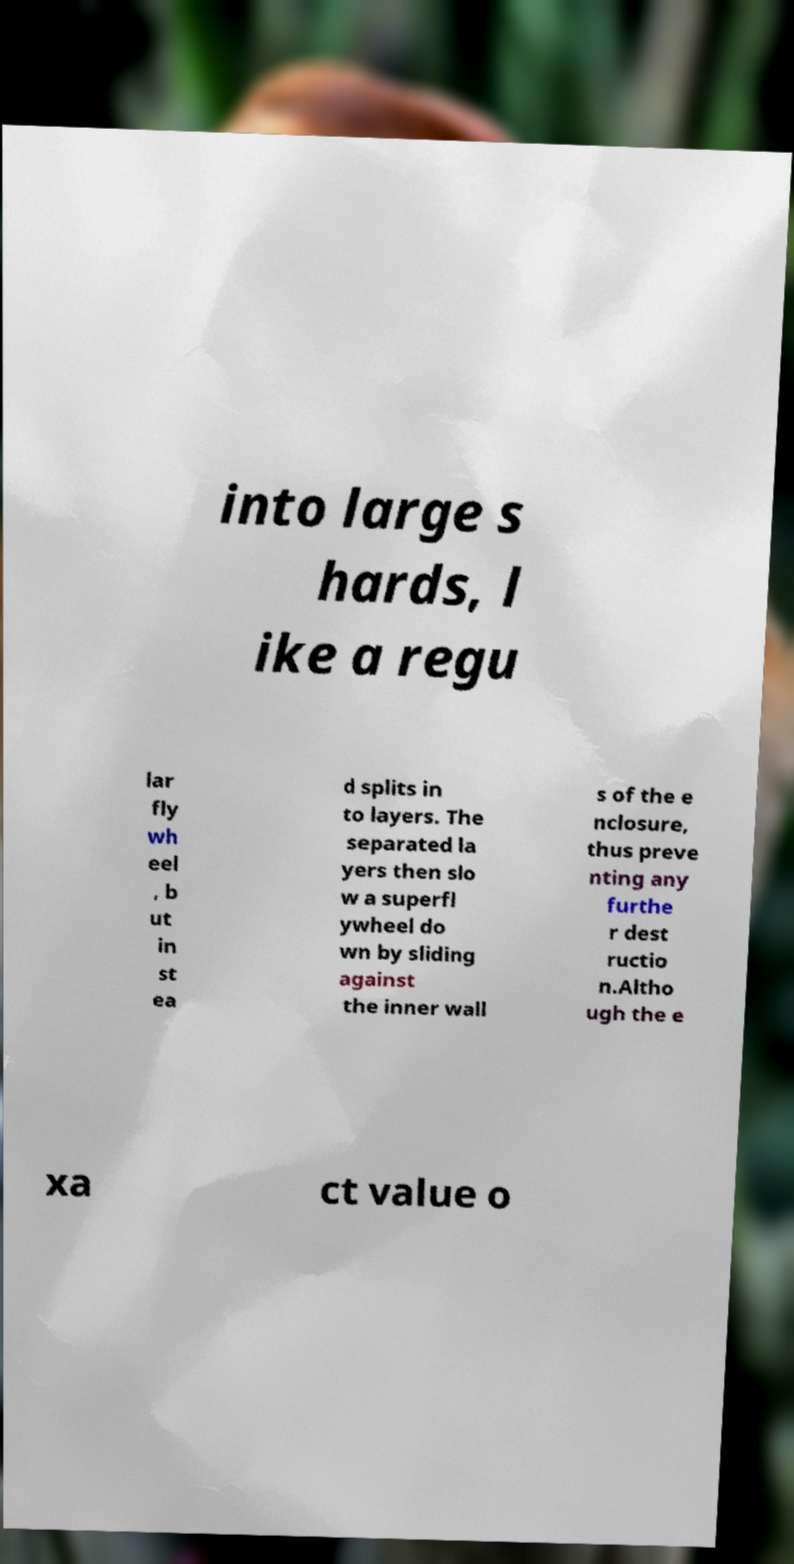Please identify and transcribe the text found in this image. into large s hards, l ike a regu lar fly wh eel , b ut in st ea d splits in to layers. The separated la yers then slo w a superfl ywheel do wn by sliding against the inner wall s of the e nclosure, thus preve nting any furthe r dest ructio n.Altho ugh the e xa ct value o 